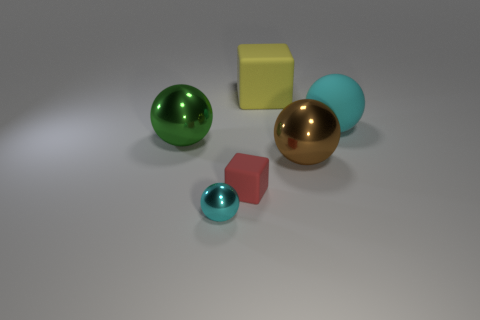Subtract 1 balls. How many balls are left? 3 Add 4 brown spheres. How many objects exist? 10 Subtract all spheres. How many objects are left? 2 Subtract 0 gray balls. How many objects are left? 6 Subtract all large cyan rubber things. Subtract all small purple balls. How many objects are left? 5 Add 1 cyan rubber objects. How many cyan rubber objects are left? 2 Add 5 green metallic balls. How many green metallic balls exist? 6 